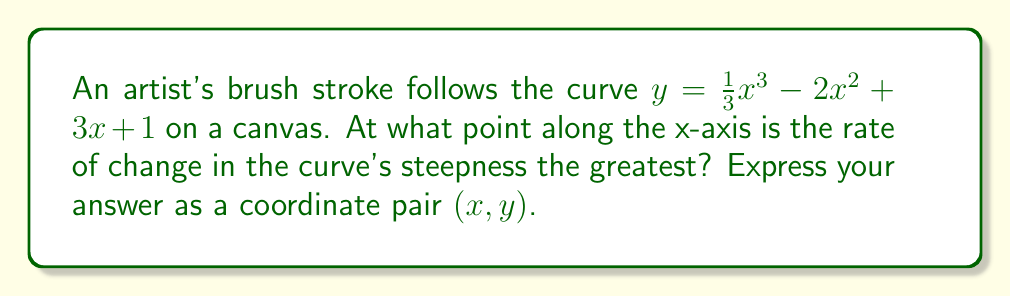Solve this math problem. To find the point where the rate of change in the curve's steepness is greatest, we need to follow these steps:

1) First, we need to find the first derivative of the curve. This represents the slope or steepness of the curve at any point:

   $y' = x^2 - 4x + 3$

2) To find where the rate of change of the steepness is greatest, we need to find the maximum of the second derivative. The second derivative represents how quickly the slope is changing:

   $y'' = 2x - 4$

3) To find the maximum of $y''$, we set it equal to zero and solve for x:

   $2x - 4 = 0$
   $2x = 4$
   $x = 2$

4) This tells us that the rate of change in steepness is greatest when $x = 2$.

5) To find the y-coordinate, we plug $x = 2$ back into the original equation:

   $y = \frac{1}{3}(2)^3 - 2(2)^2 + 3(2) + 1$
   $y = \frac{8}{3} - 8 + 6 + 1$
   $y = \frac{8}{3} - 1$
   $y = \frac{5}{3}$

Therefore, the point where the rate of change in the curve's steepness is greatest is $(2, \frac{5}{3})$.
Answer: $(2, \frac{5}{3})$ 